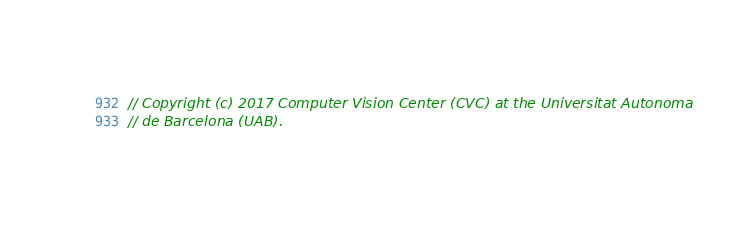<code> <loc_0><loc_0><loc_500><loc_500><_C_>// Copyright (c) 2017 Computer Vision Center (CVC) at the Universitat Autonoma
// de Barcelona (UAB).</code> 